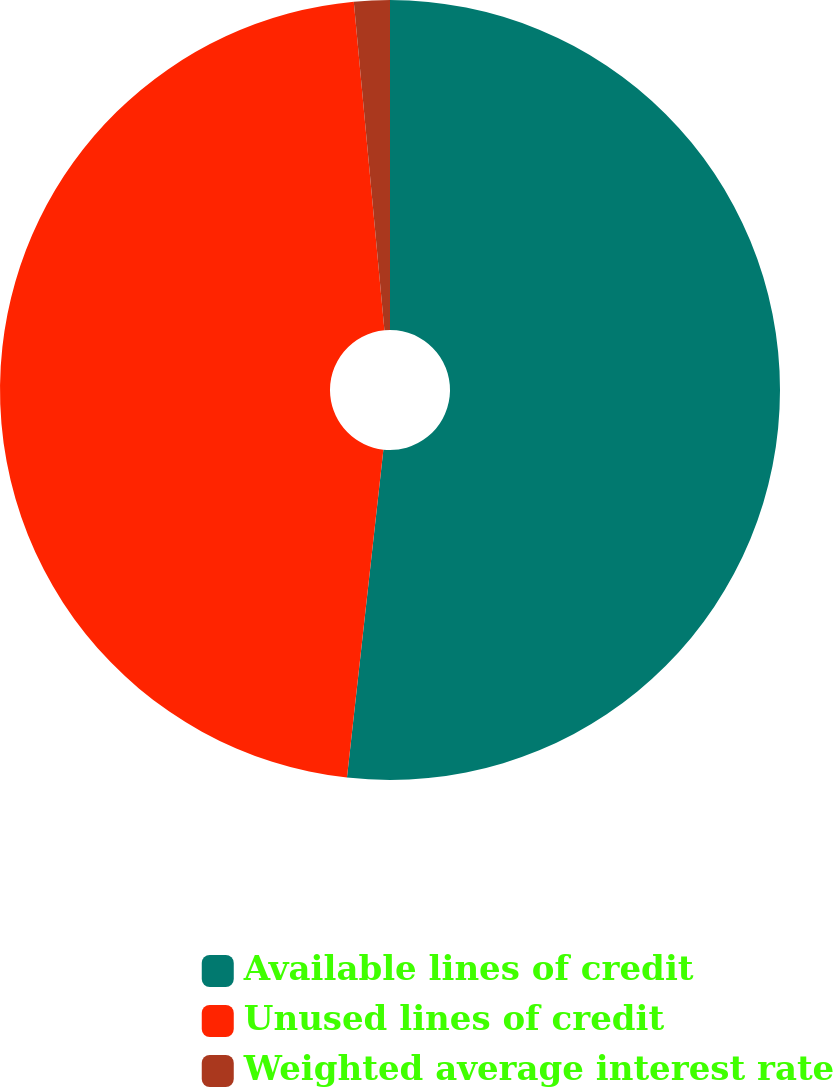<chart> <loc_0><loc_0><loc_500><loc_500><pie_chart><fcel>Available lines of credit<fcel>Unused lines of credit<fcel>Weighted average interest rate<nl><fcel>51.76%<fcel>46.76%<fcel>1.48%<nl></chart> 